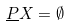<formula> <loc_0><loc_0><loc_500><loc_500>\underline { P } X = \emptyset</formula> 